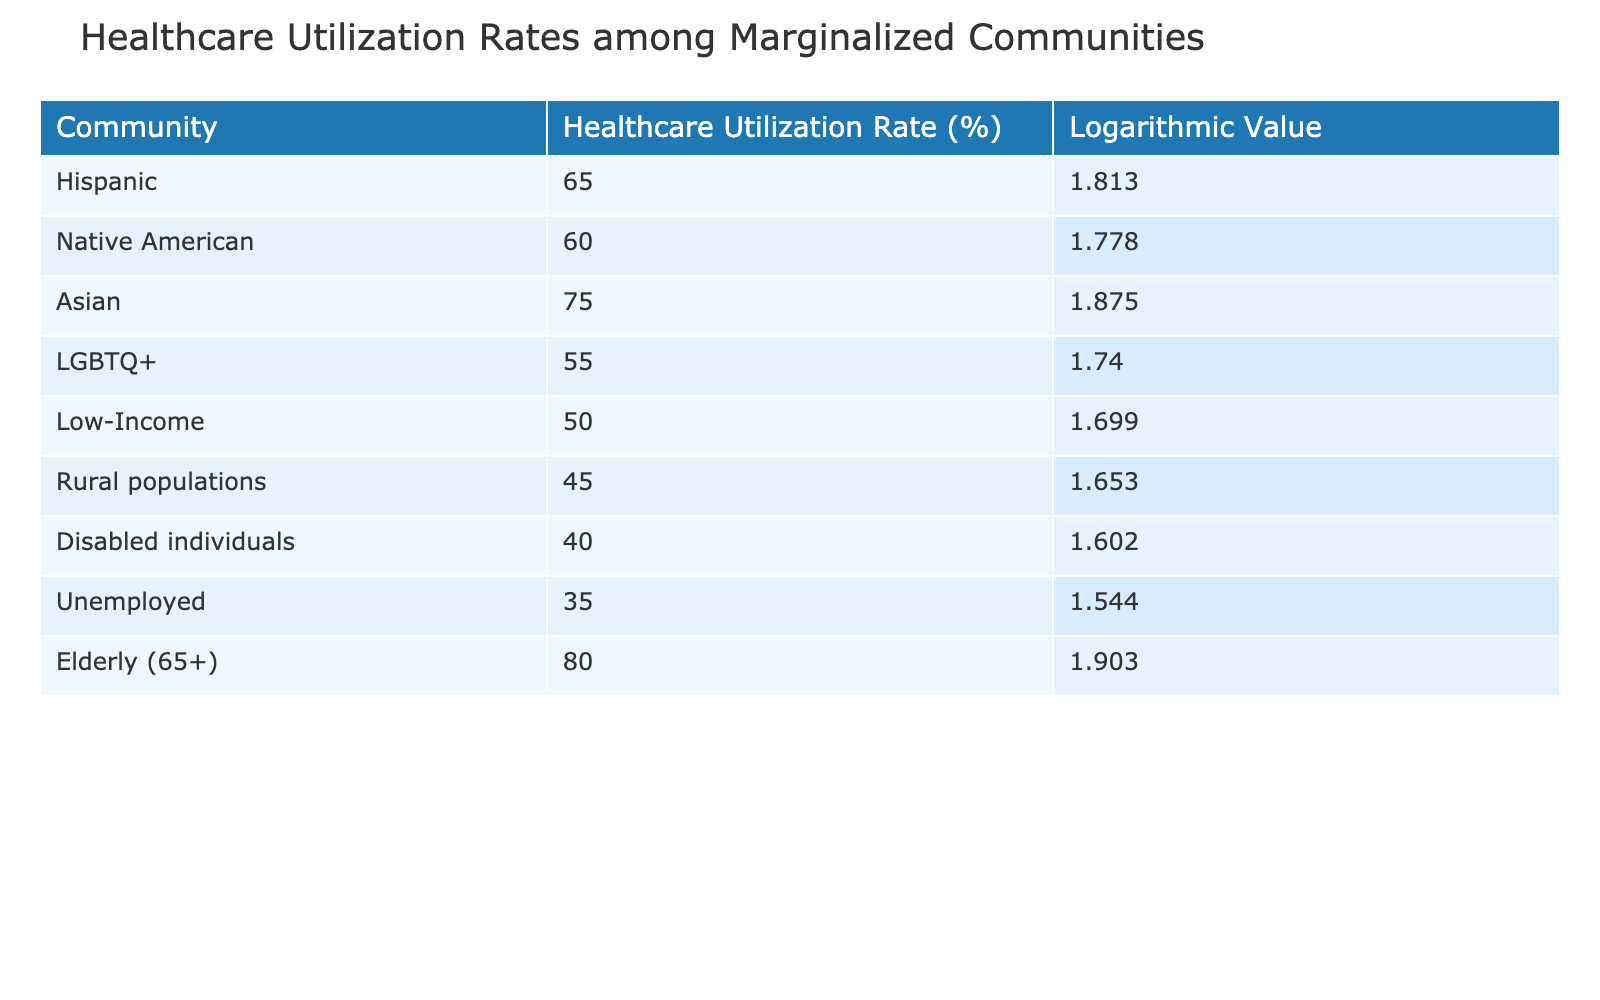What is the healthcare utilization rate for Asian communities? In the table, the section for Asian communities lists a healthcare utilization rate of 75%.
Answer: 75% Which community has the lowest healthcare utilization rate? The row corresponding to rural populations shows a healthcare utilization rate of 45%, which is the lowest among all listed communities.
Answer: Rural populations What is the logarithmic value of the healthcare utilization rate for the elderly (65+)? For the elderly (65+), the table indicates a logarithmic value of 1.903 associated with their healthcare utilization rate.
Answer: 1.903 Is the healthcare utilization rate for LGBTQ+ communities higher than that for disabled individuals? The healthcare utilization rate for LGBTQ+ communities is 55%, while for disabled individuals it is 40%. Since 55% is greater than 40%, the answer is yes.
Answer: Yes What is the difference between the healthcare utilization rates of Hispanic and low-income communities? The healthcare utilization rate for Hispanic communities is 65% and for low-income communities it is 50%. The difference is calculated as 65% - 50% = 15%.
Answer: 15% What is the average healthcare utilization rate for the groups listed? To find the average, sum the utilization rates (65 + 60 + 75 + 55 + 50 + 45 + 40 + 35 + 80) = 565. There are 9 groups, so the average is 565/9 ≈ 62.78%.
Answer: Approximately 62.78% Which community has a higher healthcare utilization rate: Native American or low-income? The table shows a healthcare utilization rate of 60% for Native American communities and 50% for low-income communities. Thus, Native American communities have a higher rate.
Answer: Native American Is the healthcare utilization rate of elderly communities the highest among all the groups? The elderly community has a utilization rate of 80%, which is the highest rate in the table as all other communities have rates lower than this.
Answer: Yes What is the sum of healthcare utilization rates for disabled individuals and unemployed communities? The healthcare utilization rate for disabled individuals is 40% and for unemployed is 35%. Therefore, the sum is 40% + 35% = 75%.
Answer: 75% 